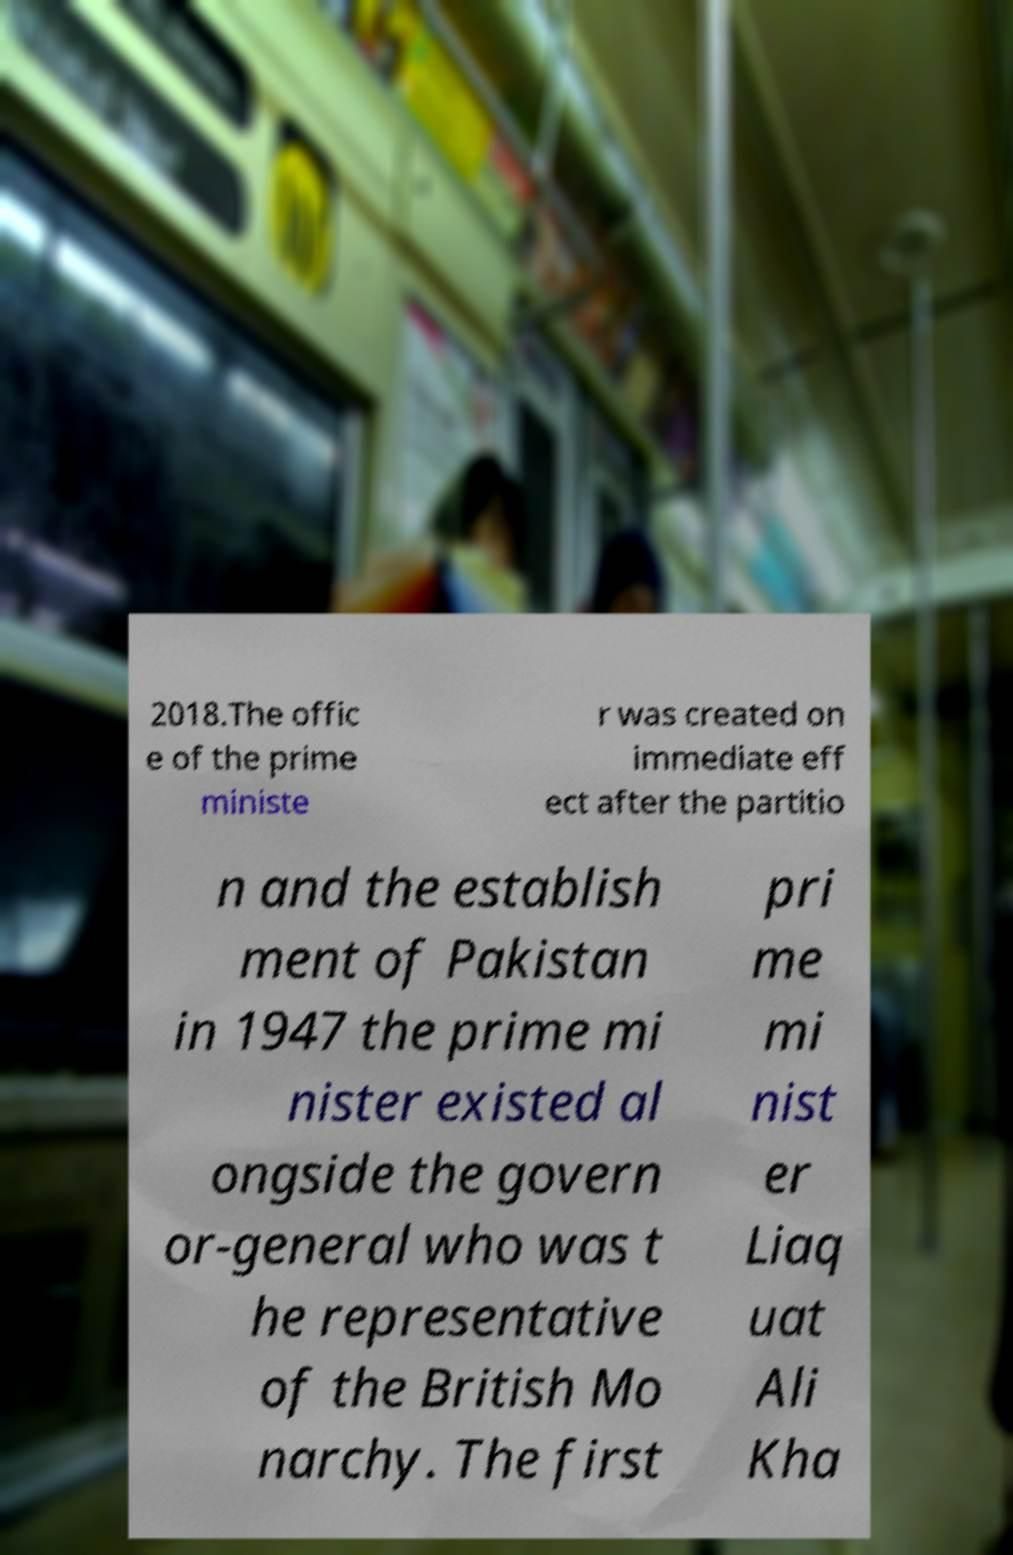Please identify and transcribe the text found in this image. 2018.The offic e of the prime ministe r was created on immediate eff ect after the partitio n and the establish ment of Pakistan in 1947 the prime mi nister existed al ongside the govern or-general who was t he representative of the British Mo narchy. The first pri me mi nist er Liaq uat Ali Kha 